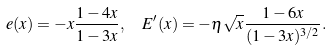<formula> <loc_0><loc_0><loc_500><loc_500>e ( x ) = - x \frac { 1 - 4 x } { 1 - 3 x } , \ \ E ^ { \prime } ( x ) = - \eta \sqrt { x } \frac { 1 - 6 x } { ( 1 - 3 x ) ^ { 3 / 2 } } .</formula> 